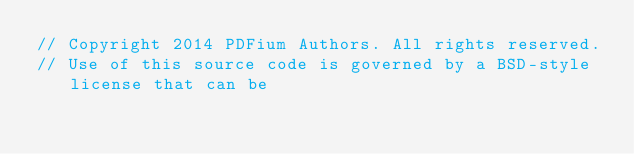Convert code to text. <code><loc_0><loc_0><loc_500><loc_500><_C++_>// Copyright 2014 PDFium Authors. All rights reserved.
// Use of this source code is governed by a BSD-style license that can be</code> 